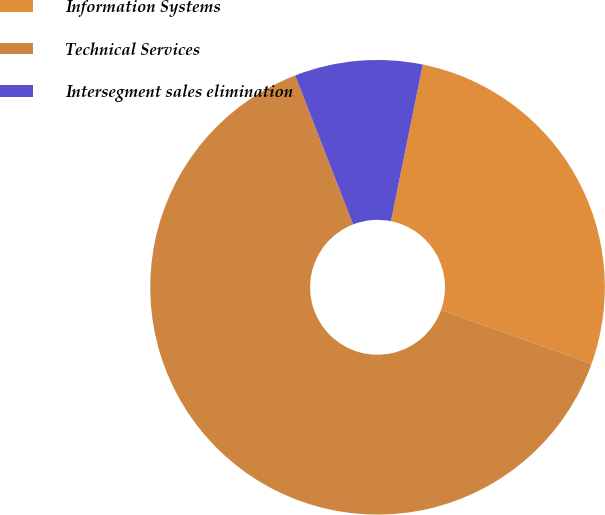Convert chart to OTSL. <chart><loc_0><loc_0><loc_500><loc_500><pie_chart><fcel>Information Systems<fcel>Technical Services<fcel>Intersegment sales elimination<nl><fcel>27.27%<fcel>63.64%<fcel>9.09%<nl></chart> 